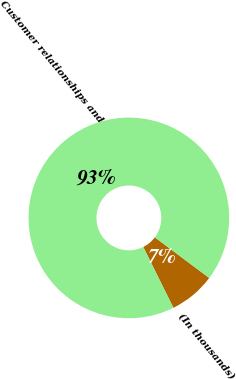<chart> <loc_0><loc_0><loc_500><loc_500><pie_chart><fcel>(In thousands)<fcel>Customer relationships and<nl><fcel>7.47%<fcel>92.53%<nl></chart> 